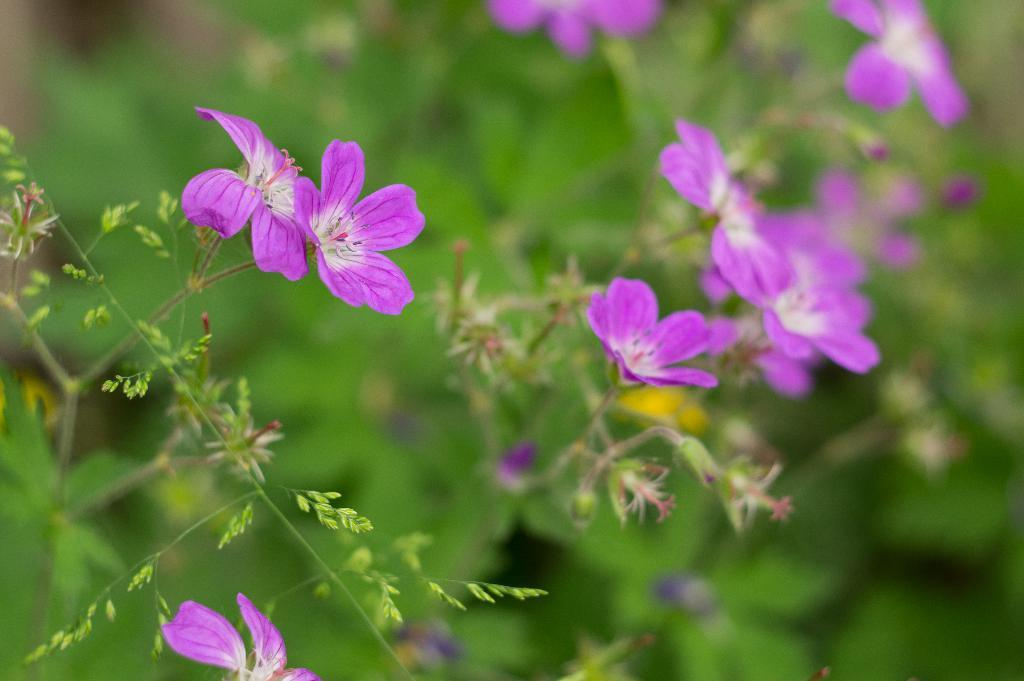What type of plants are visible in the image? There are flowers, leaves, and stems visible in the image. Can you describe the parts of the plants that are present in the image? Yes, there are flowers, leaves, and stems present in the image. Where is the girl playing the game with the scarecrow in the image? There is no girl, game, or scarecrow present in the image; it only features flowers, leaves, and stems. 